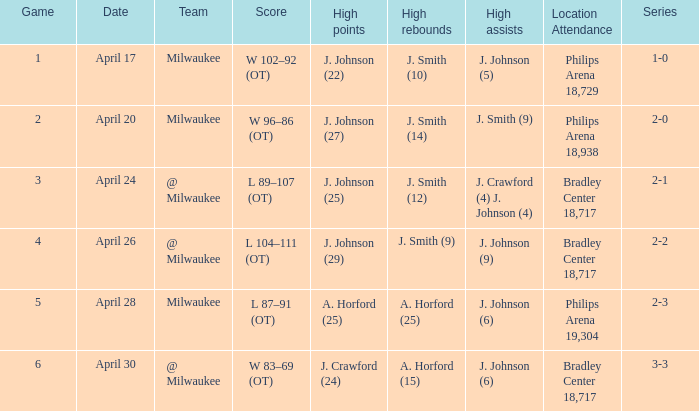What were the amount of rebounds in game 2? J. Smith (14). 